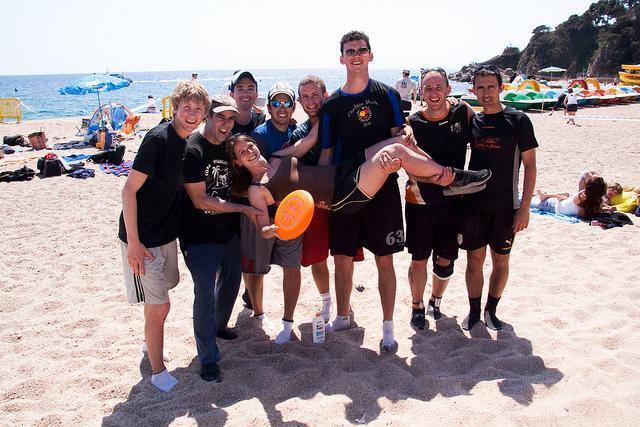How many people have sunglasses over their eyes?
Give a very brief answer. 2. How many people are in the picture?
Give a very brief answer. 8. How many green-topped spray bottles are there?
Give a very brief answer. 0. 